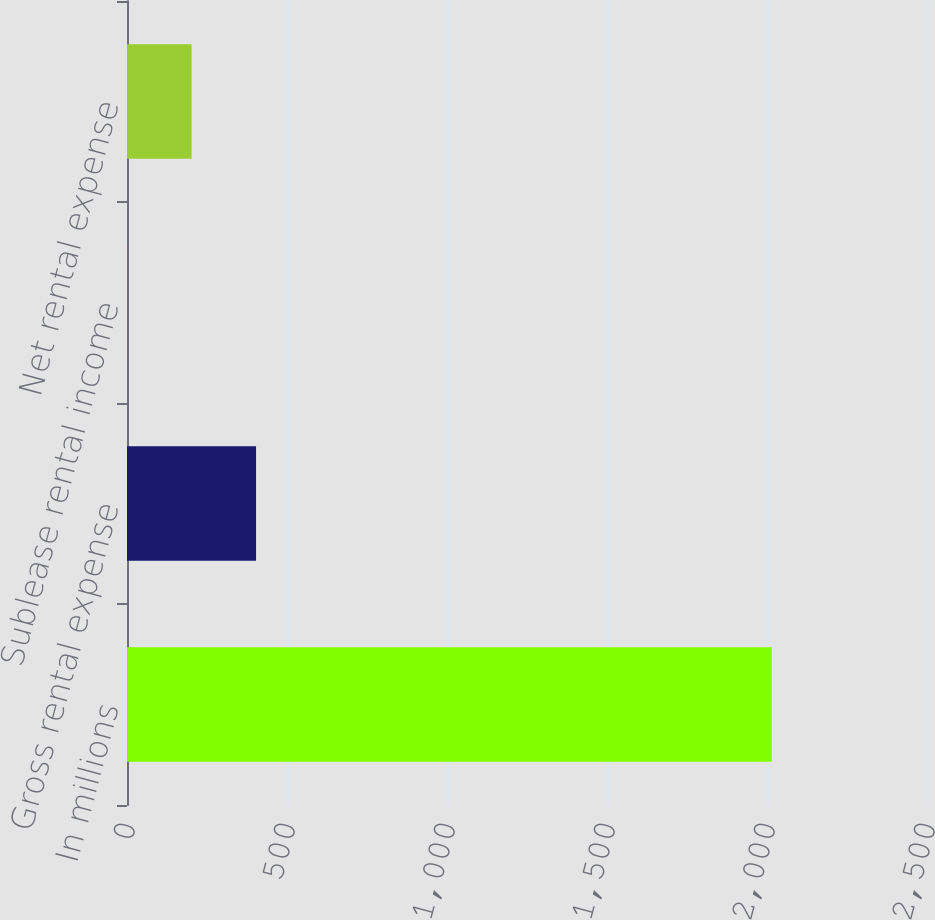<chart> <loc_0><loc_0><loc_500><loc_500><bar_chart><fcel>In millions<fcel>Gross rental expense<fcel>Sublease rental income<fcel>Net rental expense<nl><fcel>2015<fcel>403.32<fcel>0.4<fcel>201.86<nl></chart> 